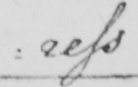Can you tell me what this handwritten text says? : ress 